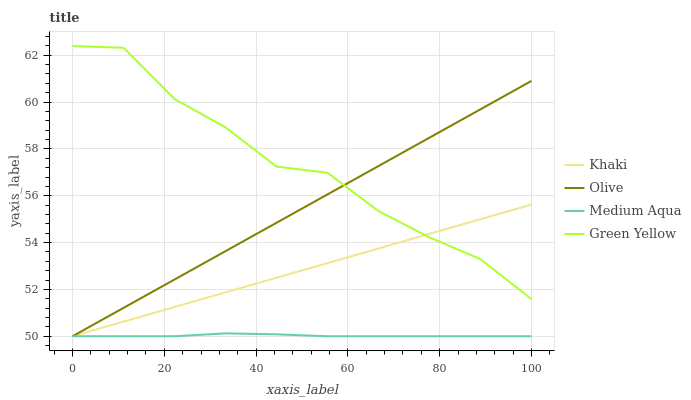Does Medium Aqua have the minimum area under the curve?
Answer yes or no. Yes. Does Green Yellow have the maximum area under the curve?
Answer yes or no. Yes. Does Khaki have the minimum area under the curve?
Answer yes or no. No. Does Khaki have the maximum area under the curve?
Answer yes or no. No. Is Khaki the smoothest?
Answer yes or no. Yes. Is Green Yellow the roughest?
Answer yes or no. Yes. Is Green Yellow the smoothest?
Answer yes or no. No. Is Khaki the roughest?
Answer yes or no. No. Does Olive have the lowest value?
Answer yes or no. Yes. Does Green Yellow have the lowest value?
Answer yes or no. No. Does Green Yellow have the highest value?
Answer yes or no. Yes. Does Khaki have the highest value?
Answer yes or no. No. Is Medium Aqua less than Green Yellow?
Answer yes or no. Yes. Is Green Yellow greater than Medium Aqua?
Answer yes or no. Yes. Does Khaki intersect Medium Aqua?
Answer yes or no. Yes. Is Khaki less than Medium Aqua?
Answer yes or no. No. Is Khaki greater than Medium Aqua?
Answer yes or no. No. Does Medium Aqua intersect Green Yellow?
Answer yes or no. No. 